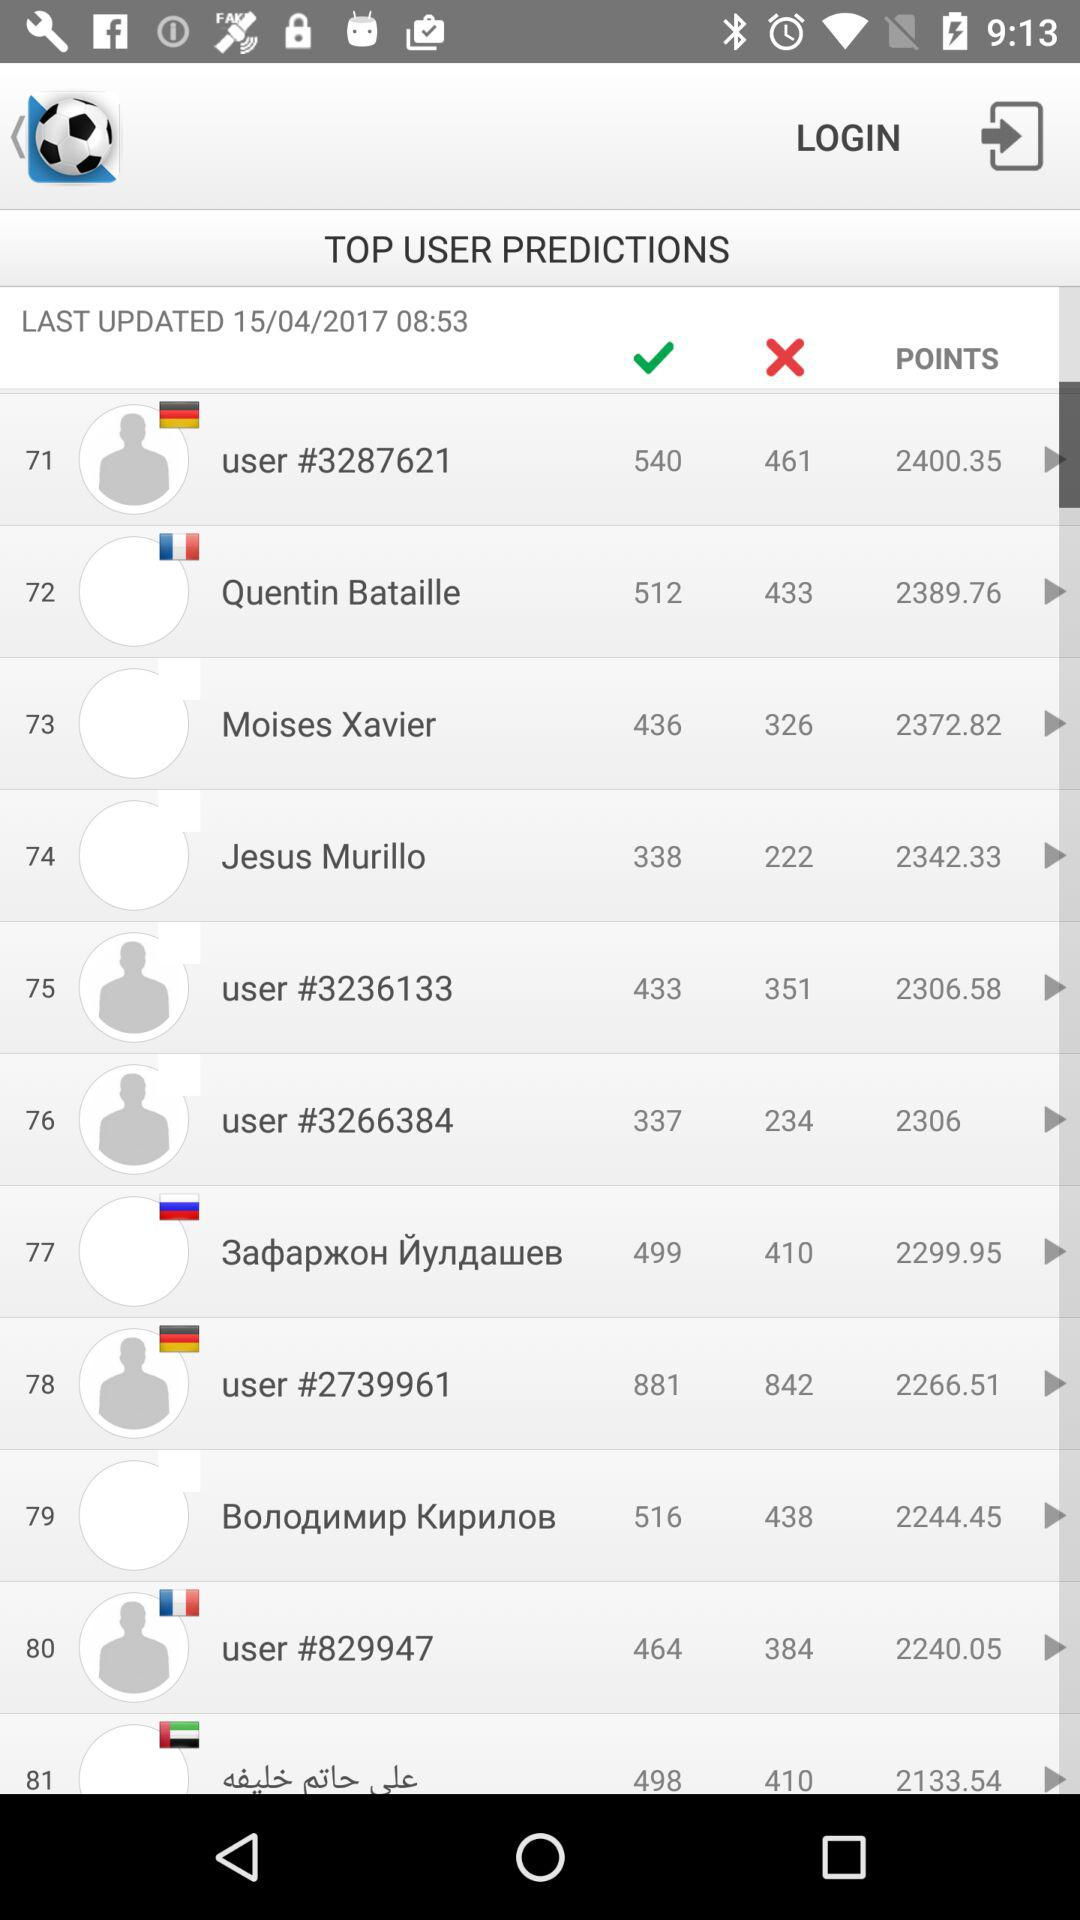What are the points of "Quentin Bataille"? The points are 2389.76. 